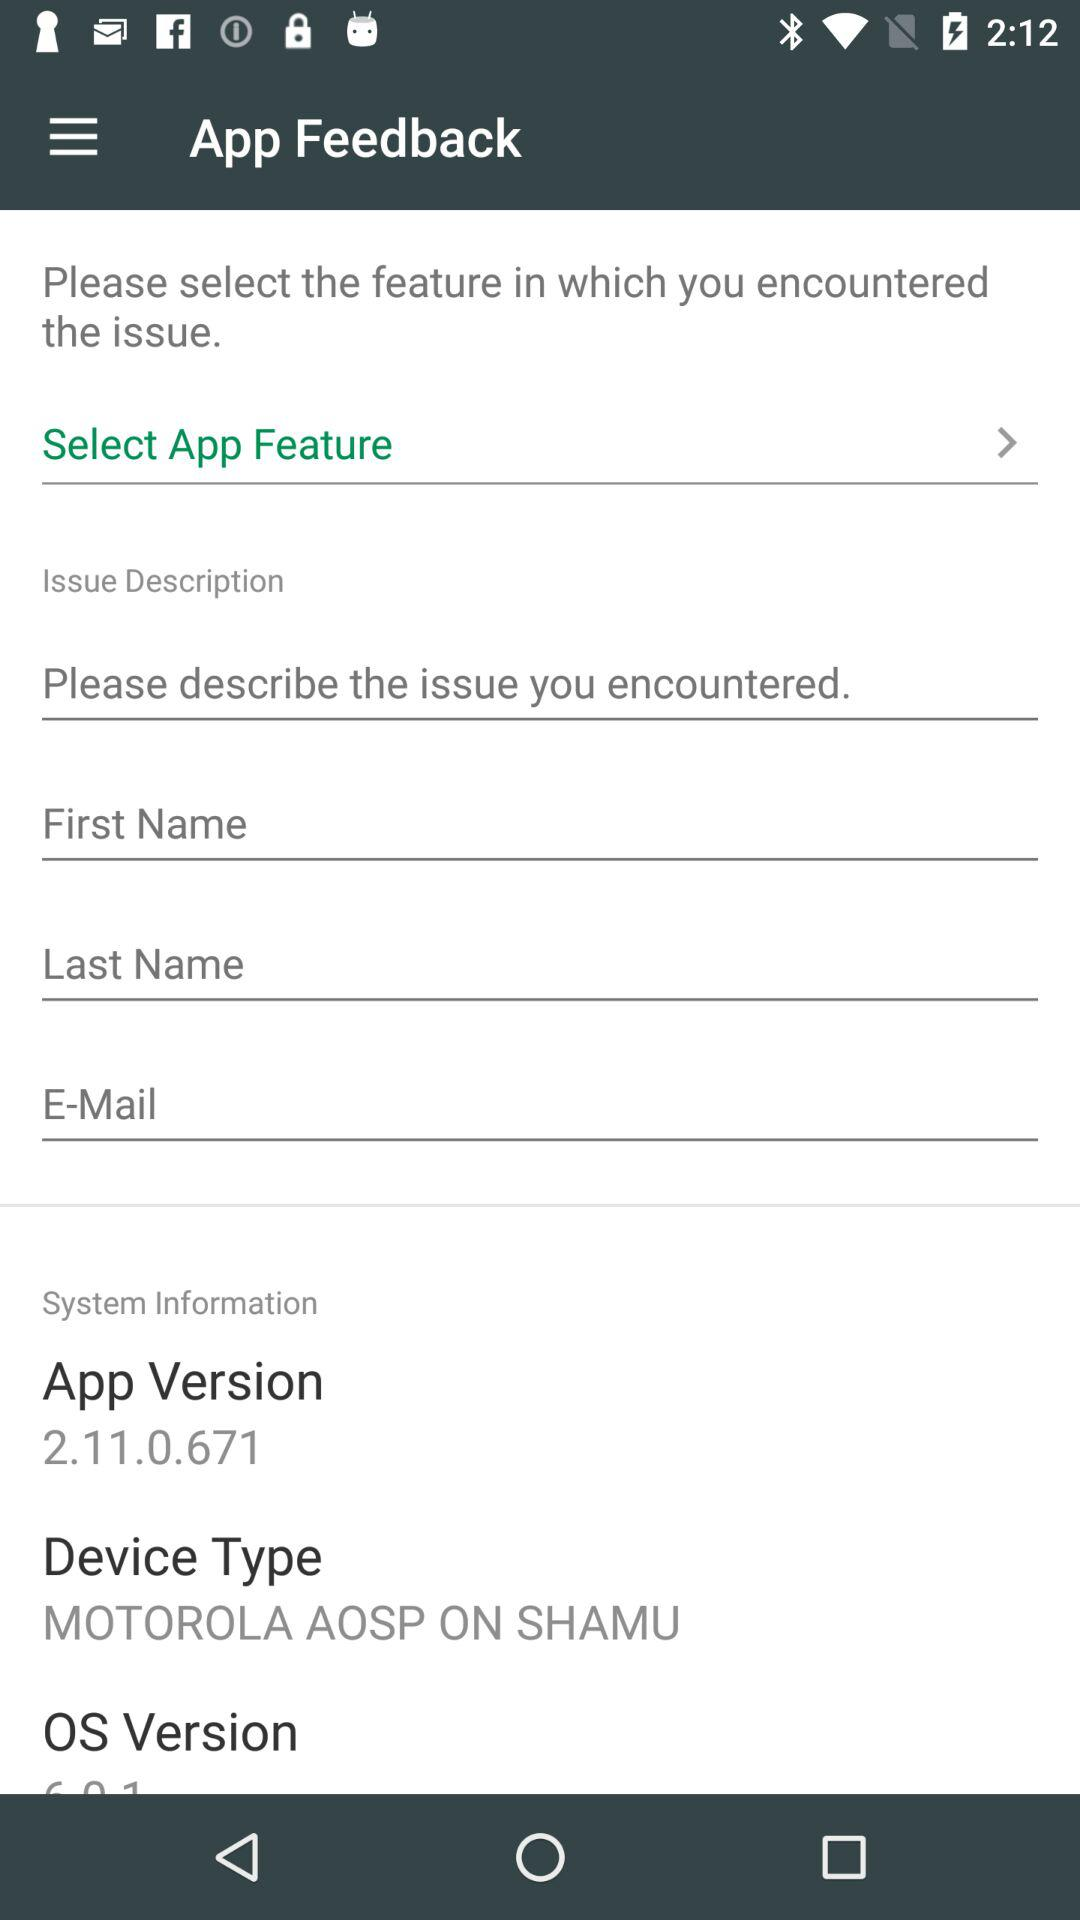How many different types of system information are there in the system information section?
Answer the question using a single word or phrase. 3 